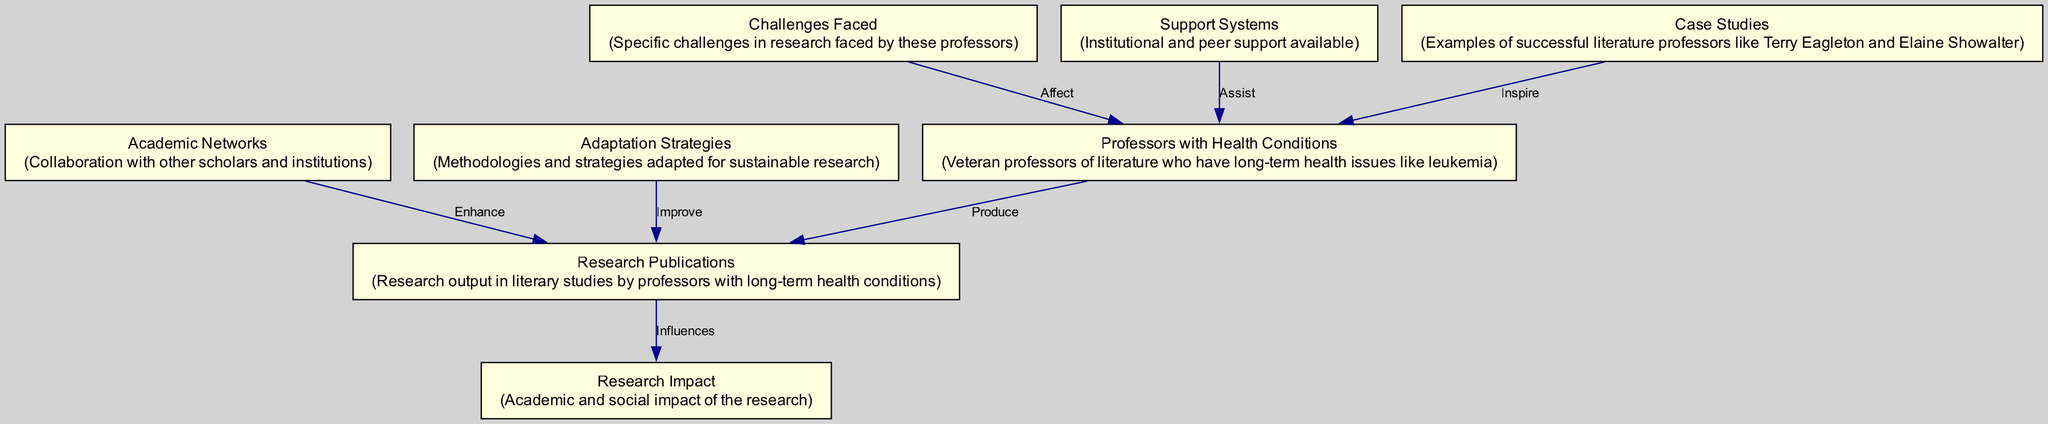What is the total number of nodes in the diagram? The diagram lists eight different entities, categorized as nodes in the visual representation. By counting each unique node, we find that the total is eight.
Answer: 8 What is the primary output of professors with long-term health conditions? The diagram indicates that these professors produce research publications as their main output. The connection from "Professors with Health Conditions" to "Research Publications" illustrates this relationship.
Answer: Research Publications What influences research publications according to the diagram? The diagram shows an arrow from "Research Publications" to "Research Impact," indicating that the latter is influenced by the former. This denotes that the impact is a result of the research produced.
Answer: Research Impact Which node is positively affected by support systems? The edge from "Support Systems" directed towards "Professors with Health Conditions" suggests that these support systems assist the professors, thus they are positively affected by it.
Answer: Professors with Health Conditions What challenges face professors with health conditions? The diagram indicates a reverse connection from "Challenges Faced" to "Professors with Health Conditions," suggesting that these challenges have a negative impact on the professors. Therefore, the professors encounter challenges directly linked to their health conditions.
Answer: Challenges Faced How do adaptation strategies relate to research publications? The arrow from "Adaptation Strategies" to "Research Publications" suggests that these strategies improve the professors' output. This means adaptation strategies play a crucial role in enhancing the research publications.
Answer: Improve Which node aims to inspire professors with health conditions? The diagram displays a connection from "Case Studies" to "Professors with Health Conditions," indicating that these case studies are meant to inspire the professors within this group.
Answer: Case Studies What enhances research publications among professors? The diagram reflects that "Academic Networks" enhance "Research Publications," showing that professional collaborations and networks contribute positively to the professors' research output.
Answer: Academic Networks What are the specific challenges faced by professors with health conditions? While not explicitly stated, the direction from "Challenges Faced" to "Professors with Health Conditions" implies that various challenges exist, but the diagram does not enumerate them directly. One can infer that they are related to their health conditions.
Answer: Challenges Faced 